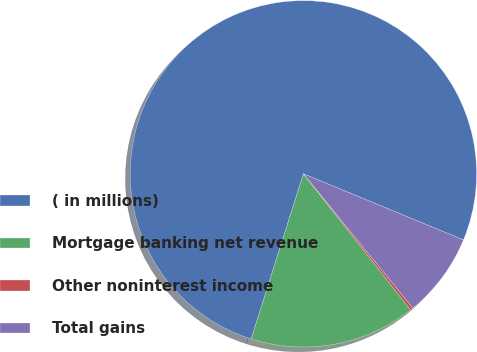Convert chart to OTSL. <chart><loc_0><loc_0><loc_500><loc_500><pie_chart><fcel>( in millions)<fcel>Mortgage banking net revenue<fcel>Other noninterest income<fcel>Total gains<nl><fcel>76.37%<fcel>15.49%<fcel>0.27%<fcel>7.88%<nl></chart> 